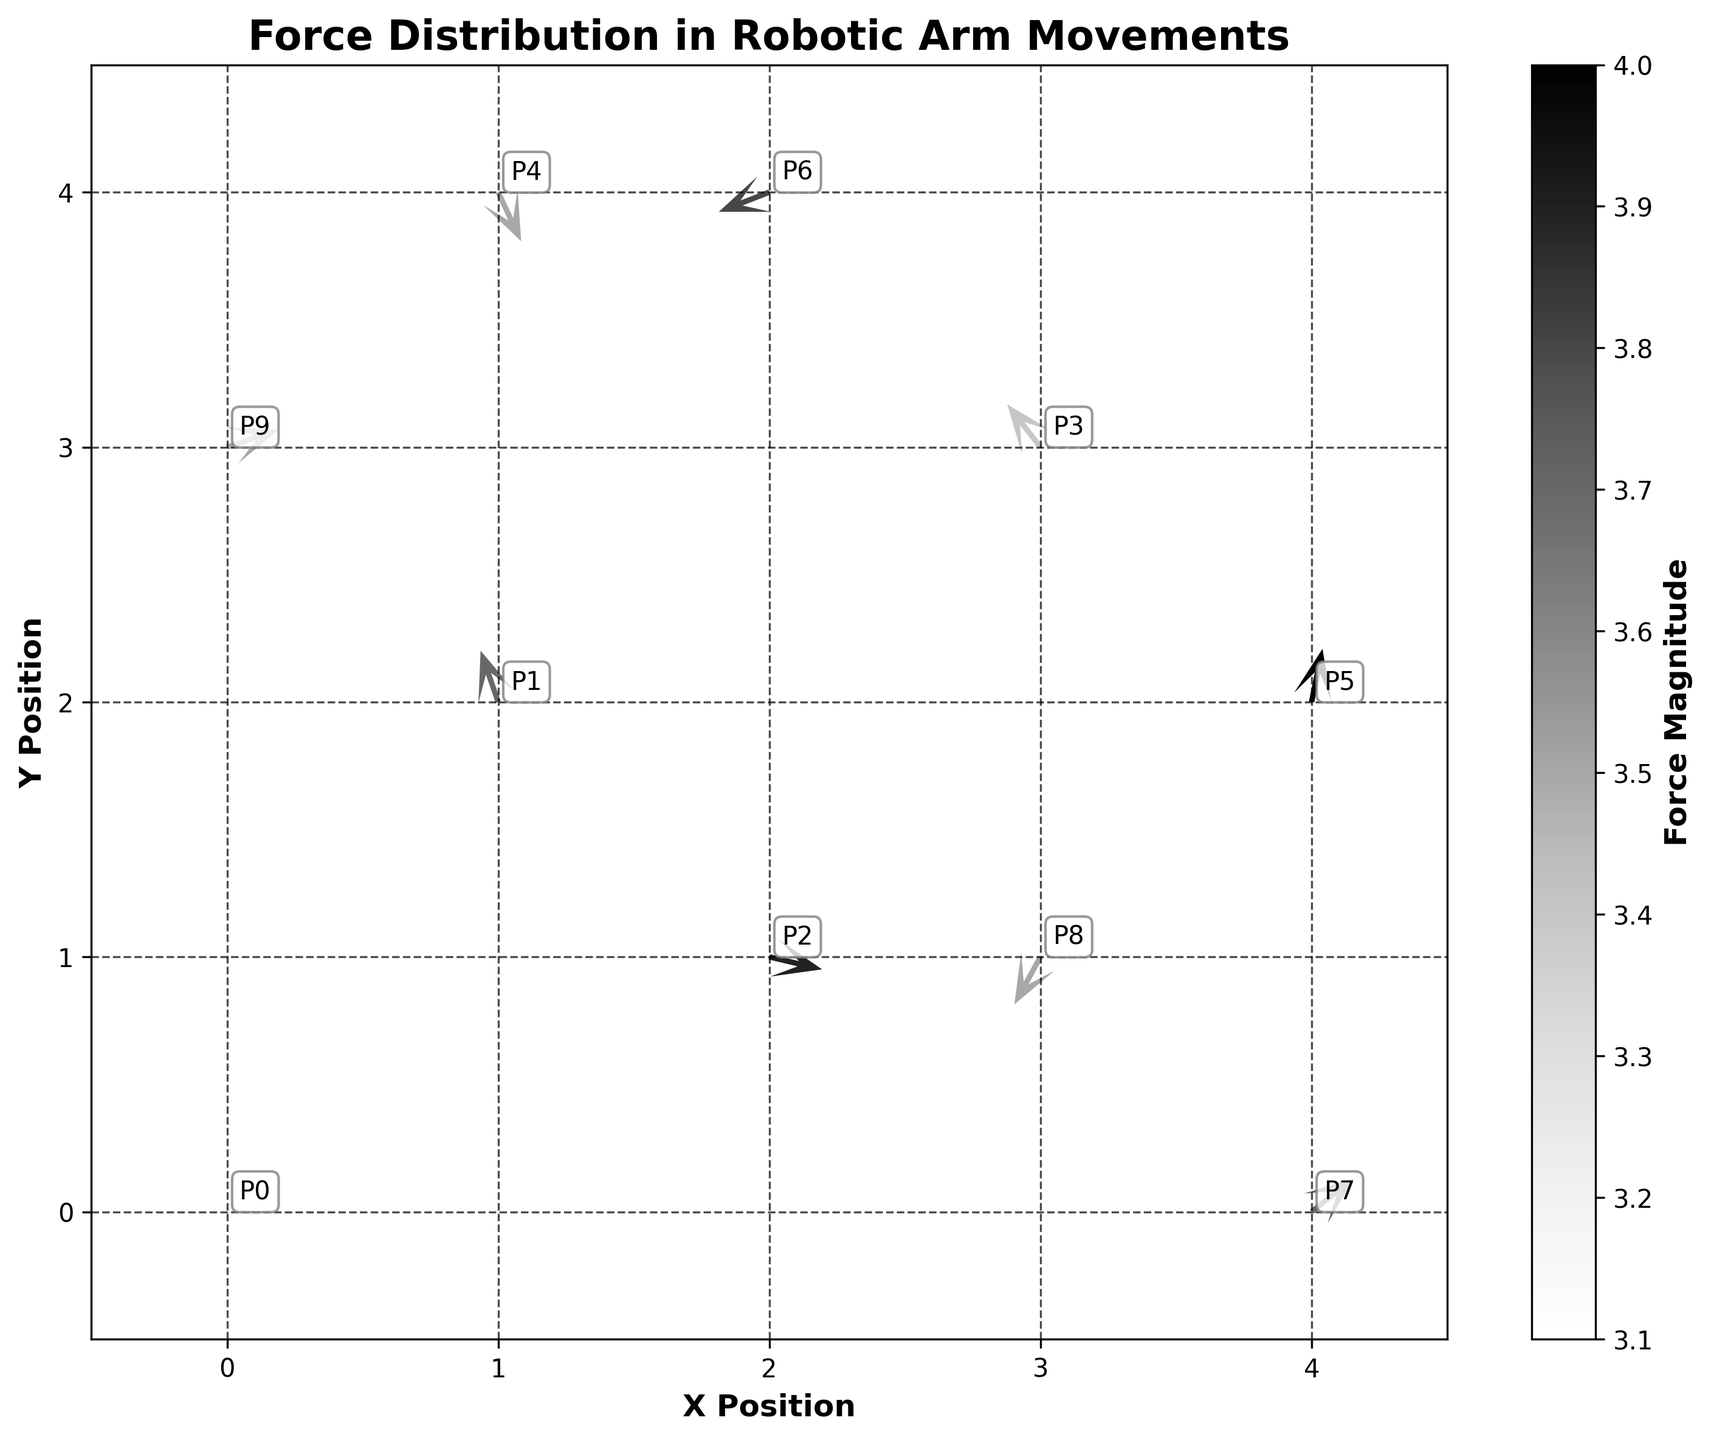What is the title of the plot? The title of the plot is usually displayed at the top, providing a brief summary of what the plot is about. In this case, it reads "Force Distribution in Robotic Arm Movements".
Answer: Force Distribution in Robotic Arm Movements What do the x and y axes represent? The labels of the x and y axes describe the parameters plotted along each axis. Here, the x-axis represents the "X Position" and the y-axis represents the "Y Position".
Answer: X Position and Y Position How many data points are visualized on the plot? Each quiver originates from a data point. Counting the individual quiver arrows will give the number of data points, which is 10.
Answer: 10 What does the color gradient in the quiver plot represent? The color gradient commonly represents a specific variable or measure. Here, it is stated in the color bar that the gradient represents the "Force Magnitude".
Answer: Force Magnitude How many vectors have a force magnitude greater than 3.7? By analyzing the color gradient and consulting the color bar, vectors showing color shades indicating magnitudes over 3.7 need to be counted. The vectors corresponding to 3.7 or higher are greater than 4 as per given colors.
Answer: 4 vectors Which vector has the largest force magnitude? To determine the largest force magnitude, identify the vector with the darkest color indicating the highest value on the color bar. Here, the vector at position (4, 2) has the largest magnitude of 4.0.
Answer: The vector at (4, 2) What is the normalized direction of the vector at position (2, 1)? The normalized direction of a vector is found by dividing each component by the vector's magnitude. For (2, 1) with components (3.8, -0.9), the direction cosines are 3.8/3.9 ≈ 0.974 and -0.9/3.9 ≈ -0.231.
Answer: (0.974, -0.231) Which vector points in the negative x direction and what is its position? Vectors pointing leftward (negative x) have a negative value in their respective u component. Here, the vector at (3, 3) has a u component of -2.1.
Answer: (3, 3) Which vectors have their components only in the first quadrant based on normalized direction? Vectors in the first quadrant have both u and v components positive after normalizing. The original directions need to be checked if they map in the first quadrant after normalization.
Answer: (0, 0), (0, 3) What is the sum of the x-components of vectors at positions (1, 2) and (4, 0)? Summing the x-components for these two vectors requires adding their u values: -1.2 (at 1, 2) + 2.9 (at 4, 0) = 1.7.
Answer: 1.7 